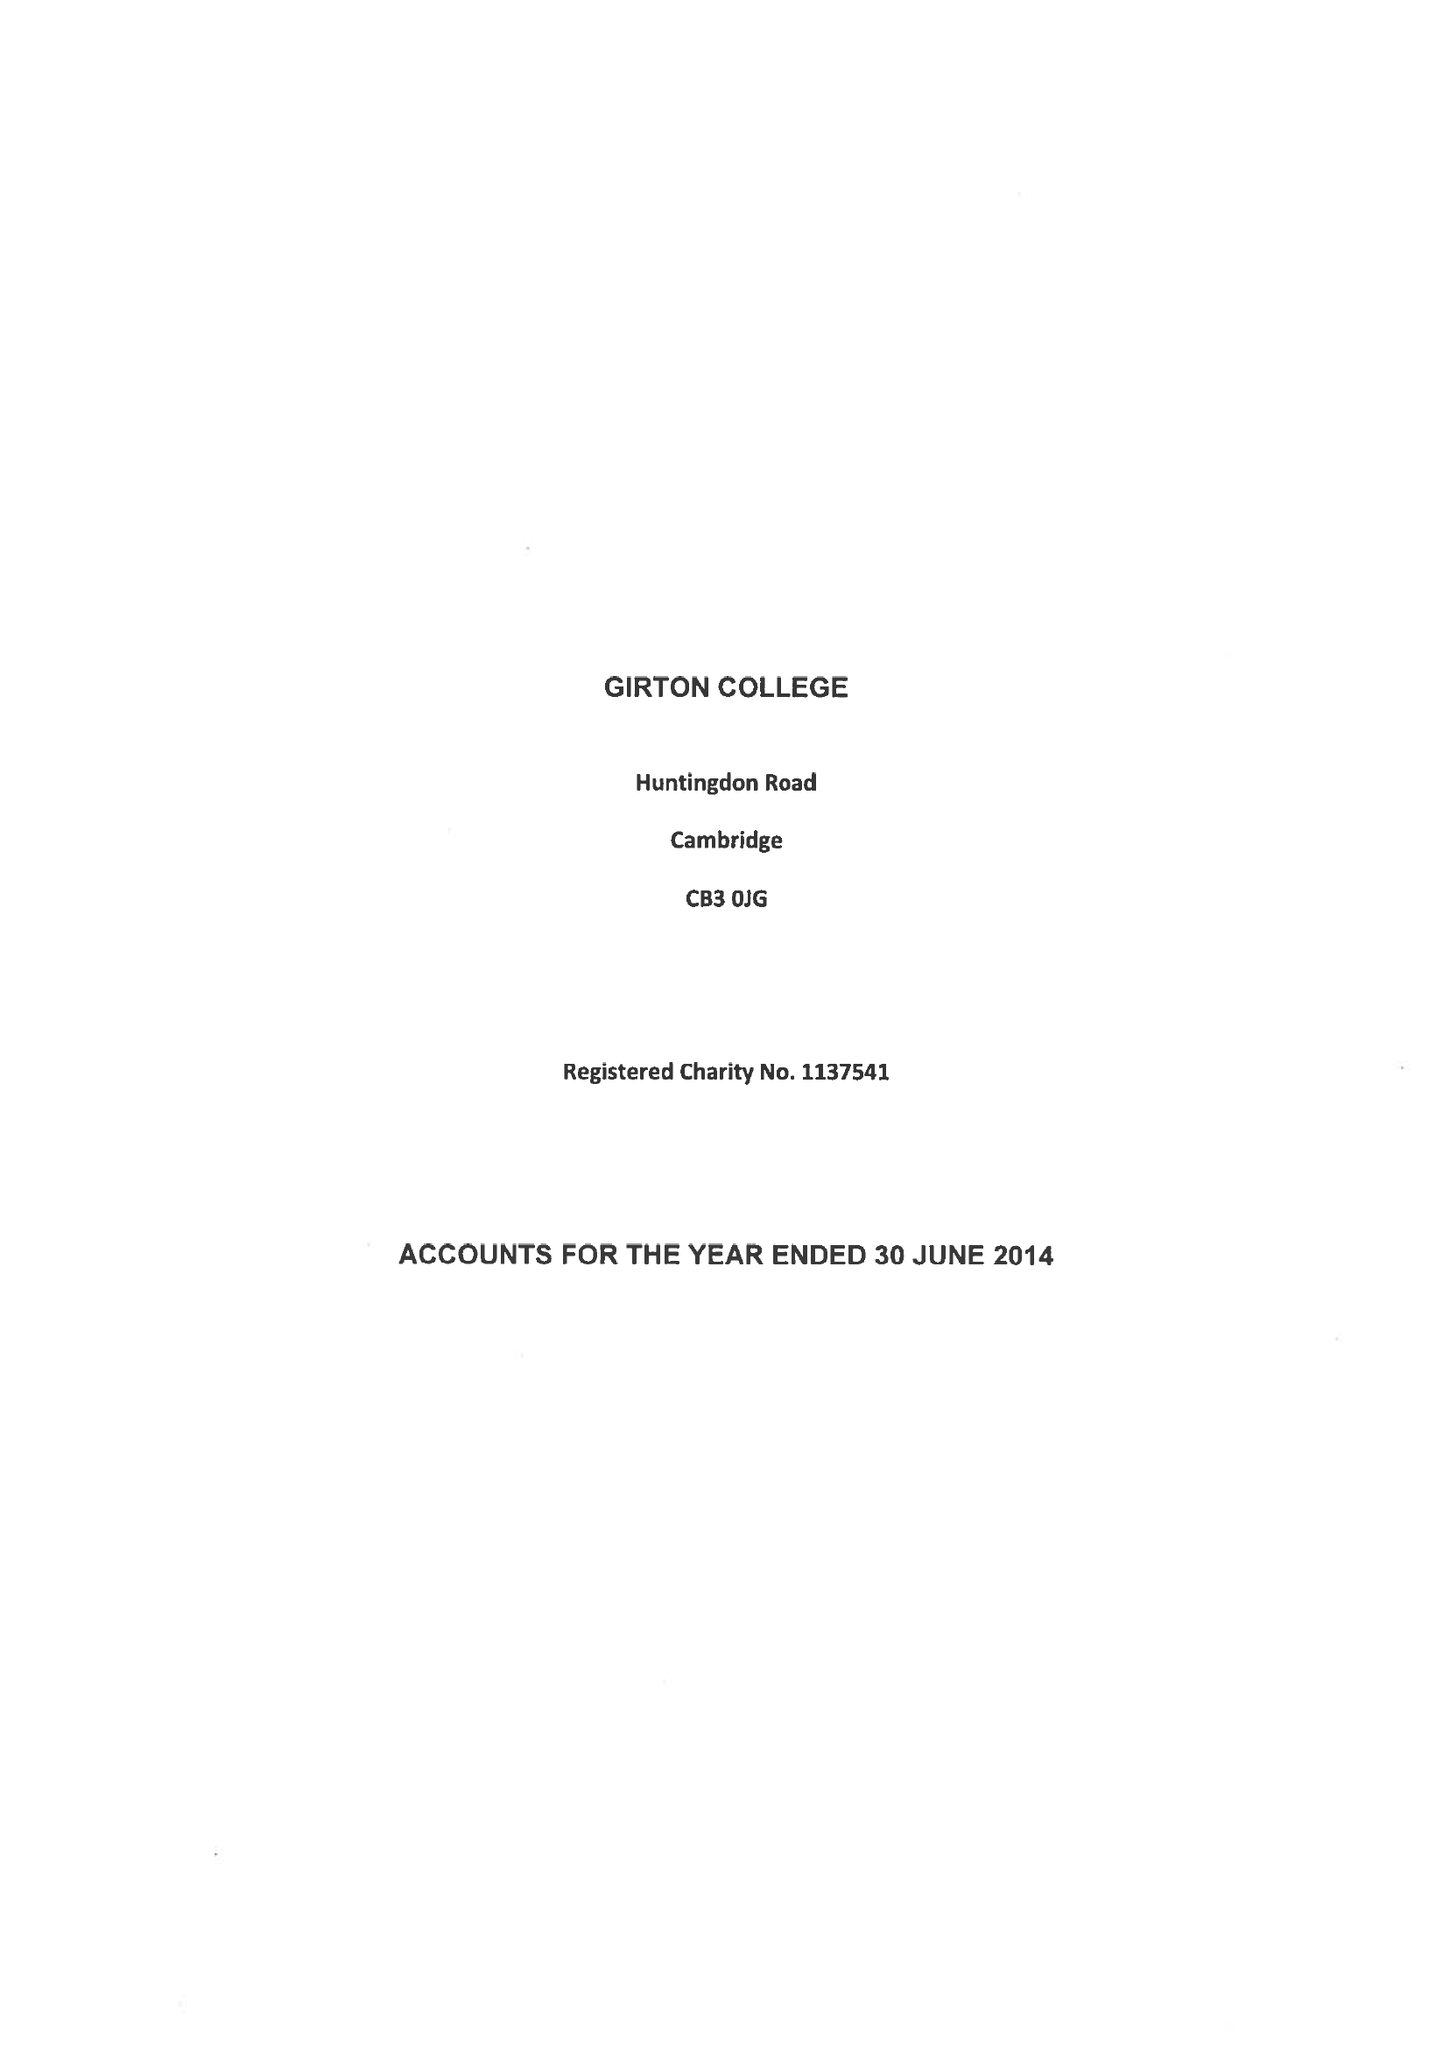What is the value for the spending_annually_in_british_pounds?
Answer the question using a single word or phrase. 10755000.00 